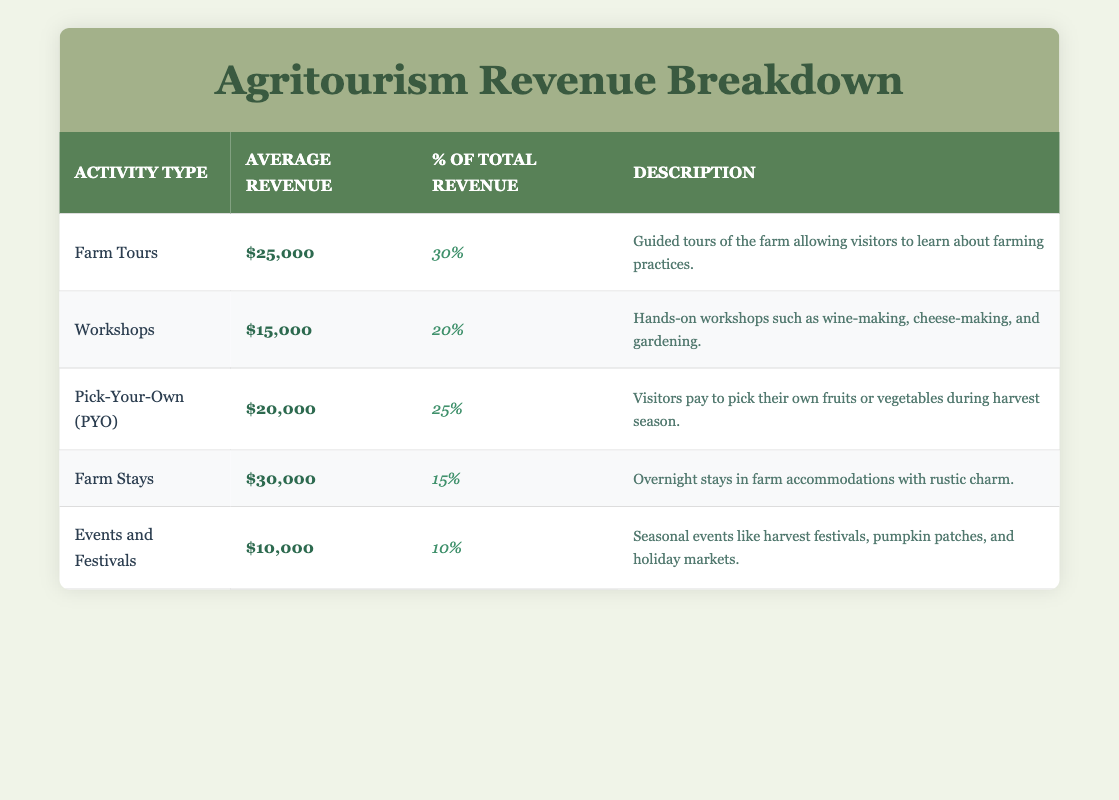What is the average revenue from Farm Stays? From the table, the average revenue for Farm Stays is listed as $30,000.
Answer: $30,000 Which activity type contributes 10% to the total revenue? According to the table, Events and Festivals contribute 10% to the total revenue as shown in its percentage of total revenue column.
Answer: Events and Festivals What is the total average revenue from Workshops and Farm Tours combined? The average revenue from Workshops is $15,000 and from Farm Tours is $25,000. Summing these gives $15,000 + $25,000 = $40,000.
Answer: $40,000 Is the percentage of total revenue for Pick-Your-Own (PYO) higher than for Farm Stays? The percentage for Pick-Your-Own (PYO) is 25% while for Farm Stays it is 15%. Since 25% is greater than 15%, the answer is yes.
Answer: Yes Which activity type has the lowest average revenue and what is that amount? The activity type with the lowest average revenue is Events and Festivals with an average revenue of $10,000, as seen in the table.
Answer: $10,000 What is the combined percentage of total revenue from Farm Tours and Workshops? The percentage of total revenue for Farm Tours is 30%, and for Workshops, it is 20%. Combining these percentages gives 30% + 20% = 50%.
Answer: 50% Do any activity types have an average revenue of $20,000 or more? Looking at the table, Farm Tours ($25,000), Pick-Your-Own (PYO) ($20,000), and Farm Stays ($30,000) all have average revenues of $20,000 or more, so the answer is yes.
Answer: Yes What is the average revenue of all listed activities? To find the average revenue of all activities, we sum the average revenues: $25,000 + $15,000 + $20,000 + $30,000 + $10,000 = $100,000. Then, we divide this total by the number of activities, which is 5: $100,000 / 5 = $20,000.
Answer: $20,000 